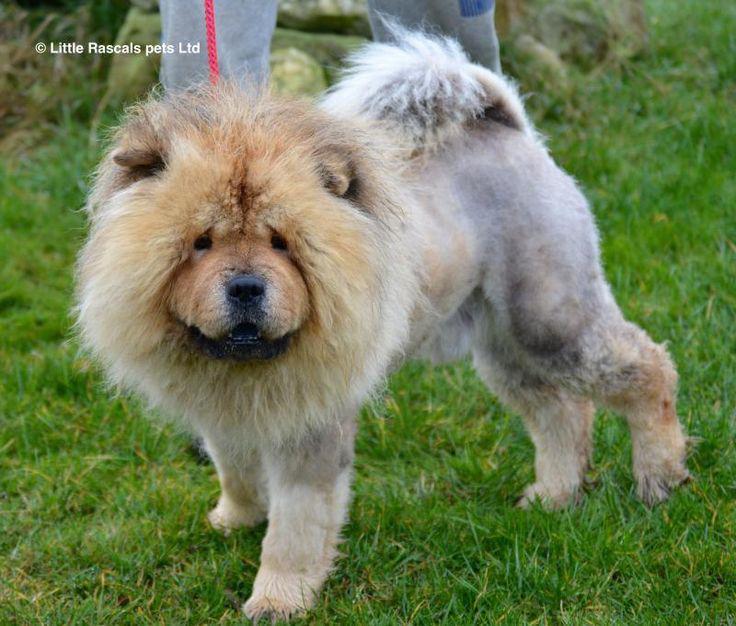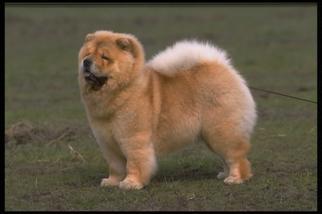The first image is the image on the left, the second image is the image on the right. Analyze the images presented: Is the assertion "Each of the images depicts a single chow dog." valid? Answer yes or no. Yes. 